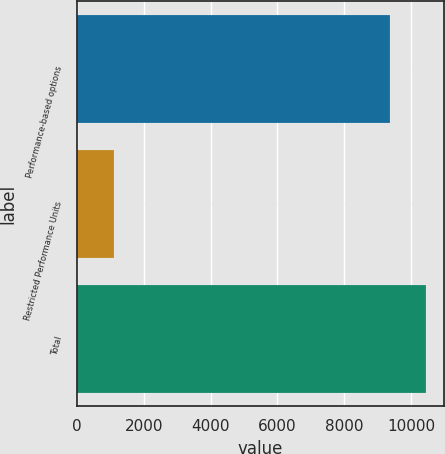Convert chart. <chart><loc_0><loc_0><loc_500><loc_500><bar_chart><fcel>Performance-based options<fcel>Restricted Performance Units<fcel>Total<nl><fcel>9363<fcel>1096<fcel>10459<nl></chart> 